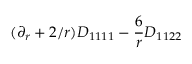Convert formula to latex. <formula><loc_0><loc_0><loc_500><loc_500>( \partial _ { r } + 2 / r ) D _ { 1 1 1 1 } - \frac { 6 } { r } D _ { 1 1 2 2 }</formula> 